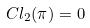Convert formula to latex. <formula><loc_0><loc_0><loc_500><loc_500>C l _ { 2 } ( \pi ) = 0</formula> 